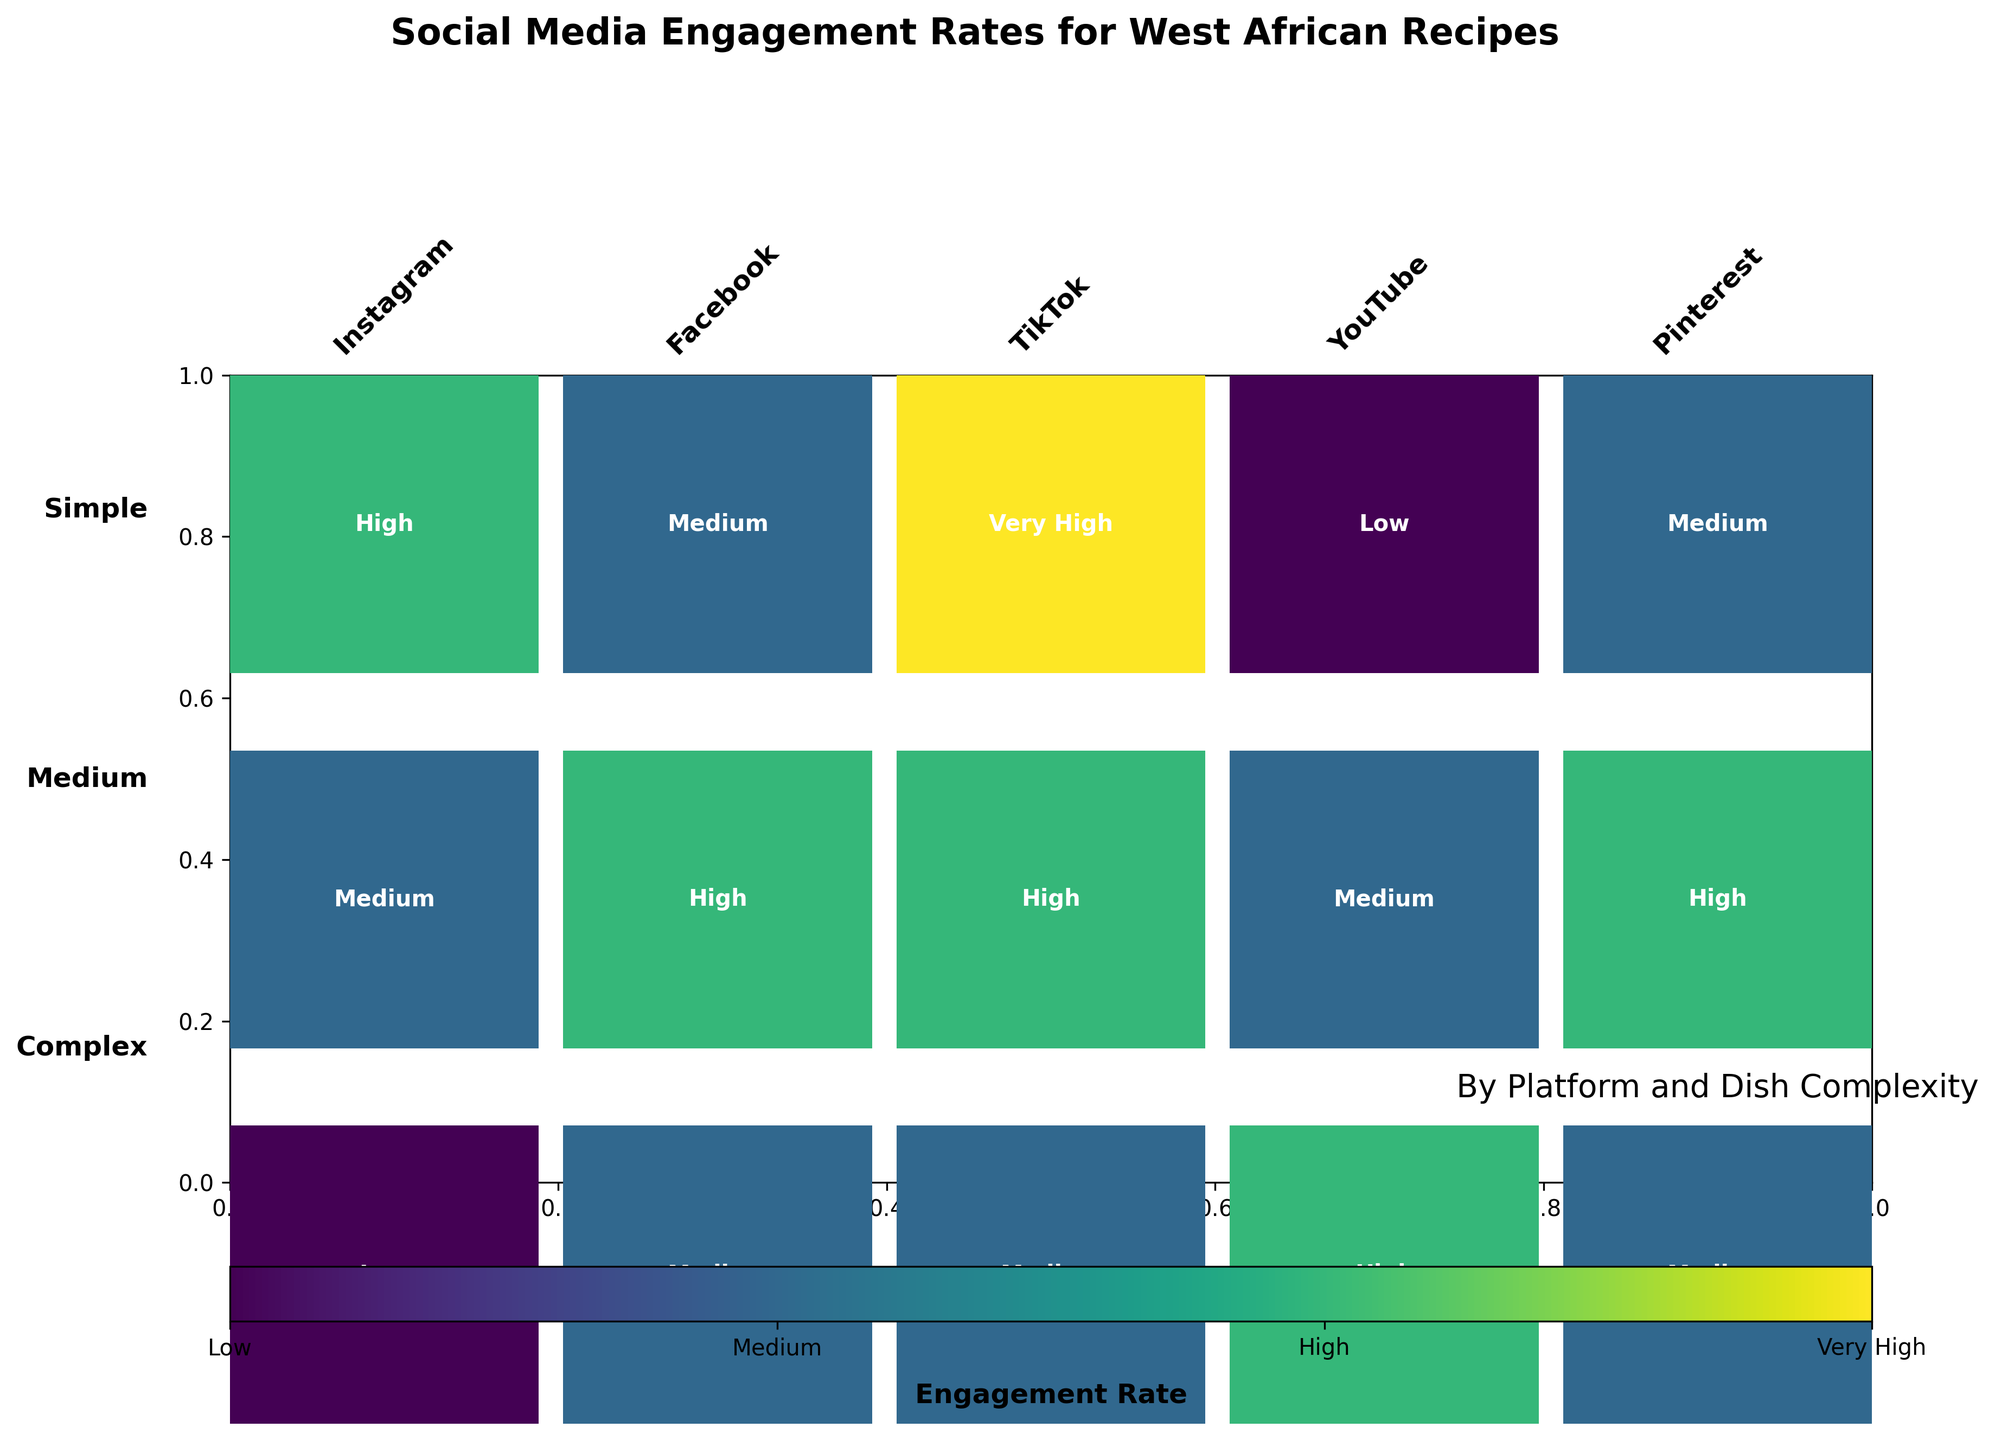What is the title of the mosaic plot? The title is typically located at the top of the plot. Look at the topmost text to find the main title and its subtitle (if any).
Answer: Social Media Engagement Rates for West African Recipes Which platform has the highest engagement rate for simple dishes? To find this, look for the "Simple" row in the mosaic plot and identify which platform has the highest engagement rate.
Answer: TikTok Which dish complexity has the lowest engagement rate on Instagram? By examining the Instagram column in the mosaic plot, find the color and label corresponding to the lowest engagement rate.
Answer: Complex Which platform has a higher engagement rate for medium complexity dishes, Facebook or Instagram? Compare the engagement rates for medium complexity dishes in the columns for Facebook and Instagram. Identify which one is higher.
Answer: Facebook What is the engagement rate for complex dishes on YouTube? Look at the intersection of complex dishes and the YouTube column.
Answer: High Compare the engagement rates for simple dishes on TikTok and Pinterest. Which one is higher? Check the Simple row for TikTok and Pinterest and see which has a higher engagement rate.
Answer: TikTok How many platforms show a "Medium" engagement rate for complex dishes? Count the number of platforms in the Complex row that are labeled with "Medium" engagement rates.
Answer: 3 Considering all dish complexities together, which platform generally shows the highest engagement rates? Observe the overall trend across different complexities for each platform to determine which one has higher engagement rates more frequently.
Answer: TikTok Is there any platform that shows "Very High" engagement rate for any dish complexity other than TikTok? Look for the "Very High" label across all platforms other than TikTok.
Answer: No Which dish complexity on Instagram has the lowest engagement rate, and what is it? Examine the Instagram column and find the lowest engagement rate, along with its corresponding dish complexity.
Answer: Complex, Low 